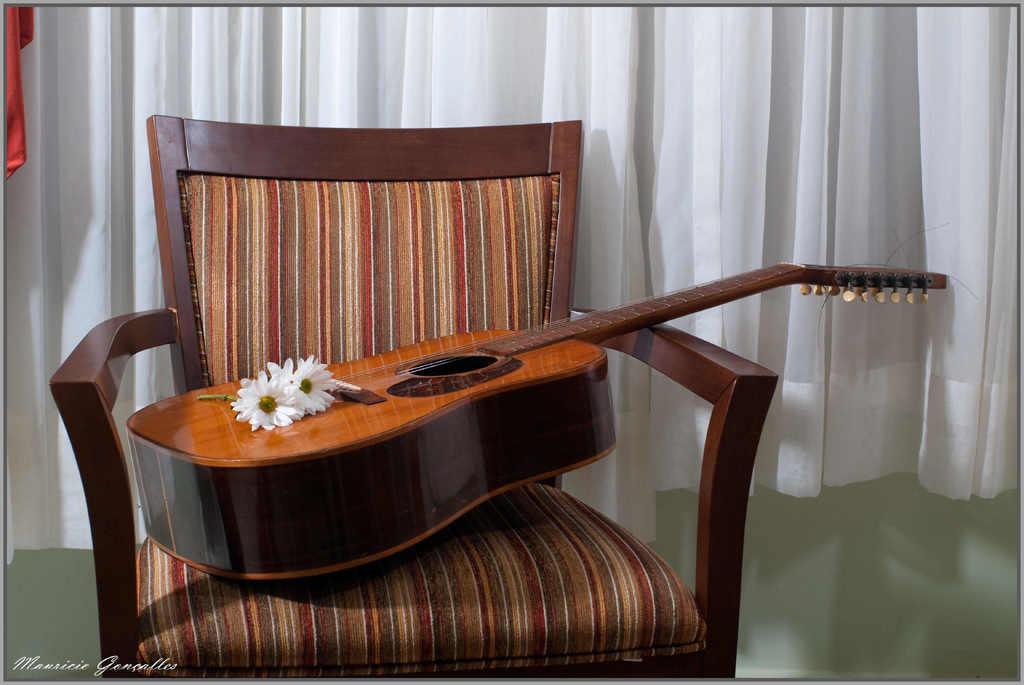In one or two sentences, can you explain what this image depicts? In this picture there is a guitar, flowers on the chair. There is a curtain. 